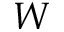<formula> <loc_0><loc_0><loc_500><loc_500>W</formula> 